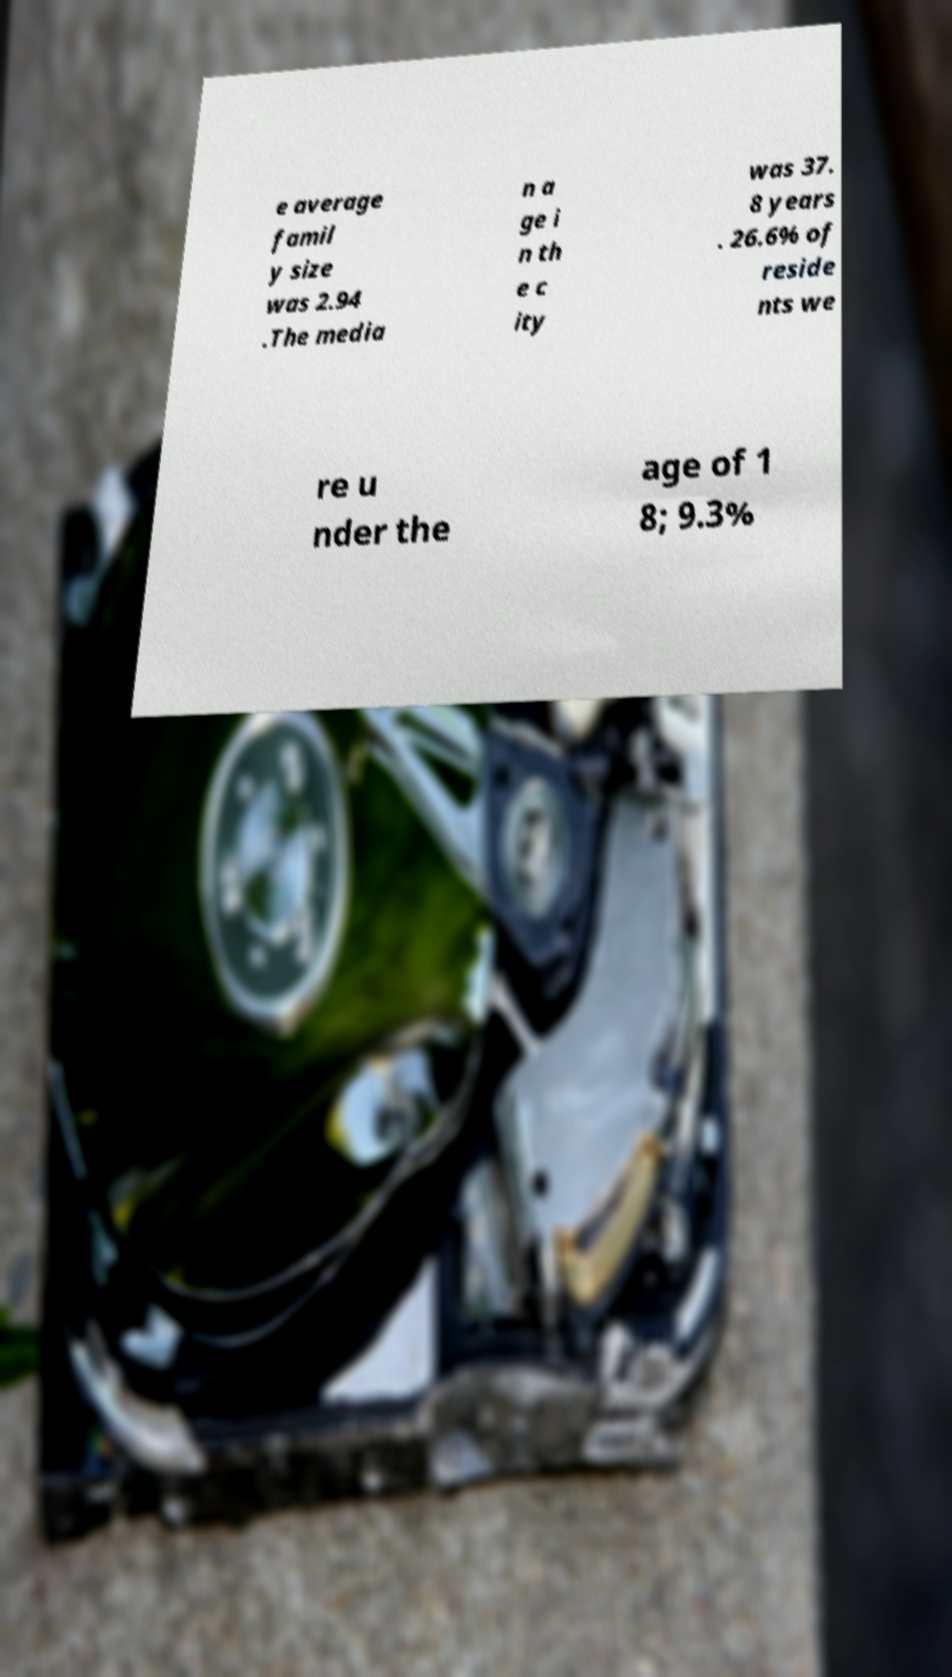Please identify and transcribe the text found in this image. e average famil y size was 2.94 .The media n a ge i n th e c ity was 37. 8 years . 26.6% of reside nts we re u nder the age of 1 8; 9.3% 